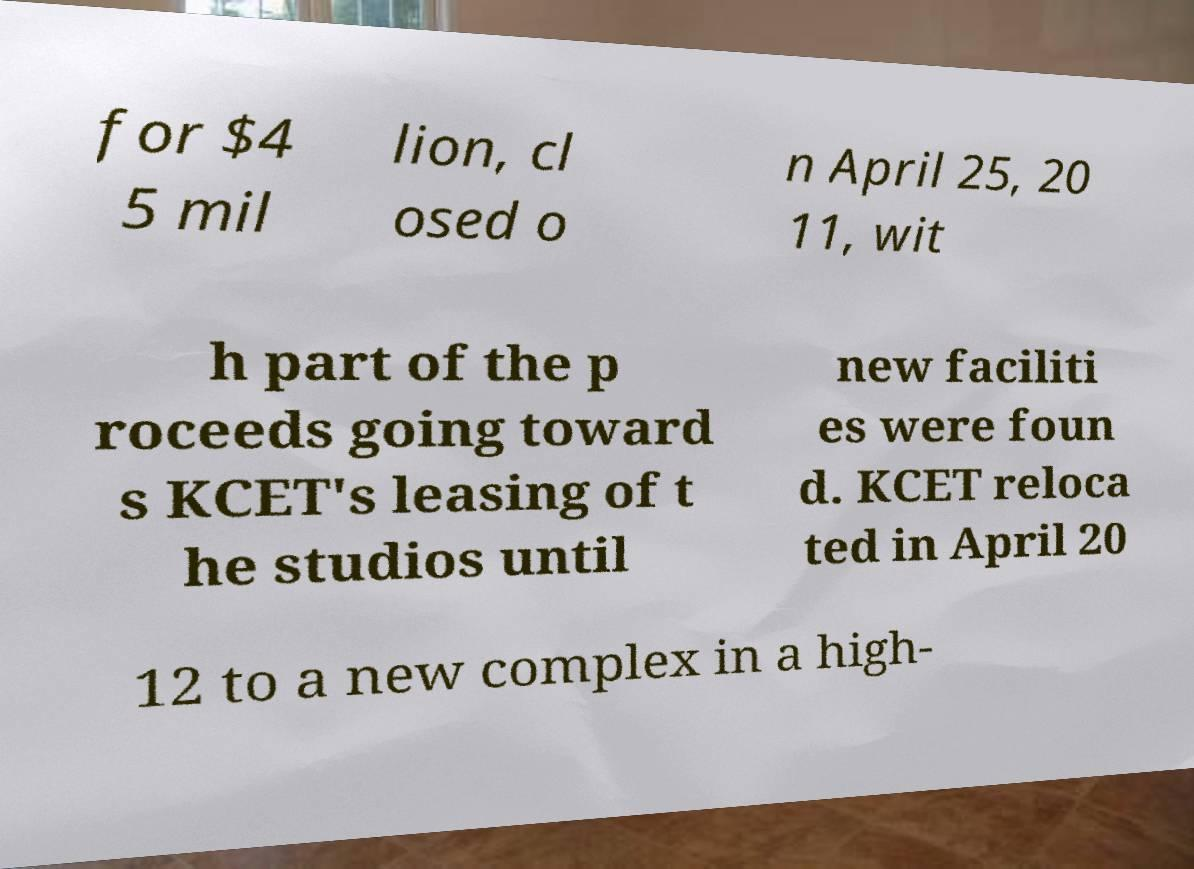What messages or text are displayed in this image? I need them in a readable, typed format. for $4 5 mil lion, cl osed o n April 25, 20 11, wit h part of the p roceeds going toward s KCET's leasing of t he studios until new faciliti es were foun d. KCET reloca ted in April 20 12 to a new complex in a high- 